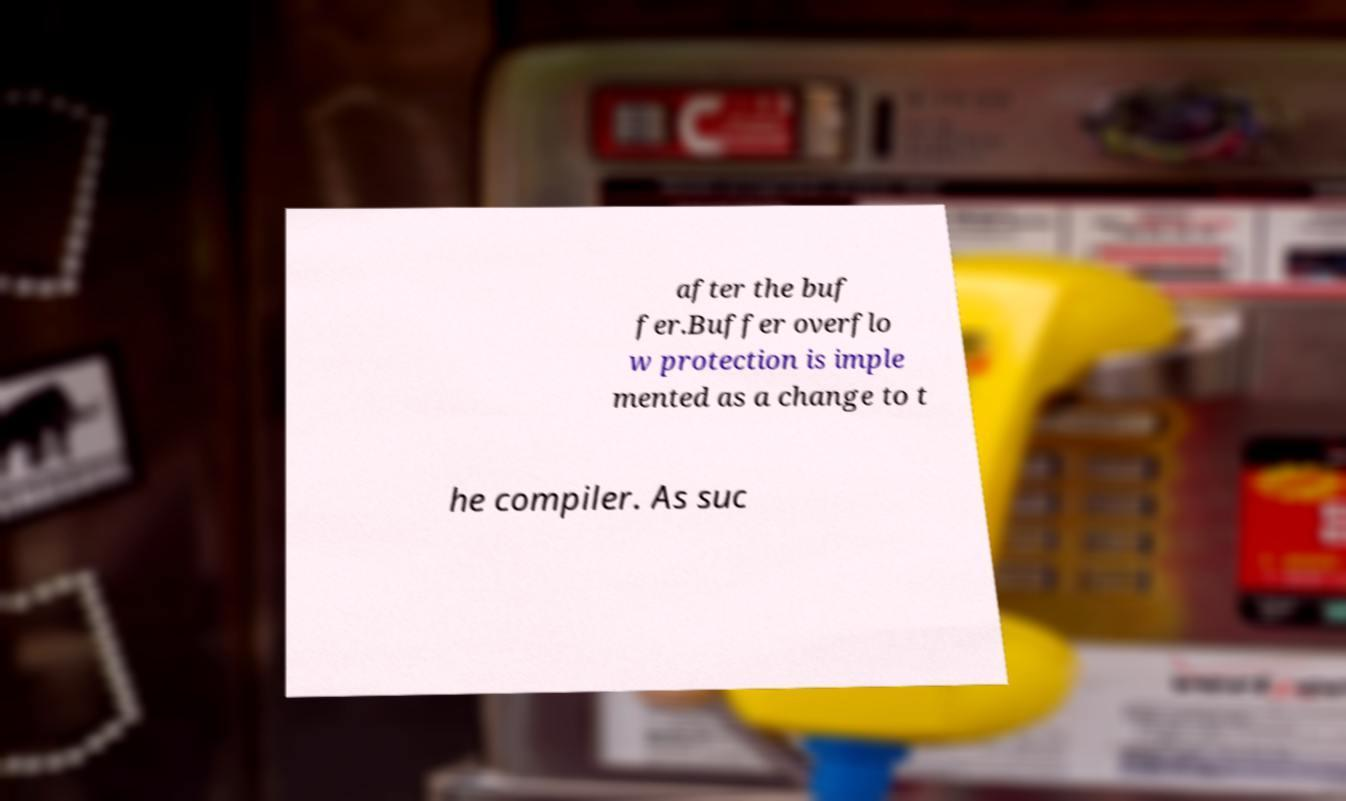There's text embedded in this image that I need extracted. Can you transcribe it verbatim? after the buf fer.Buffer overflo w protection is imple mented as a change to t he compiler. As suc 